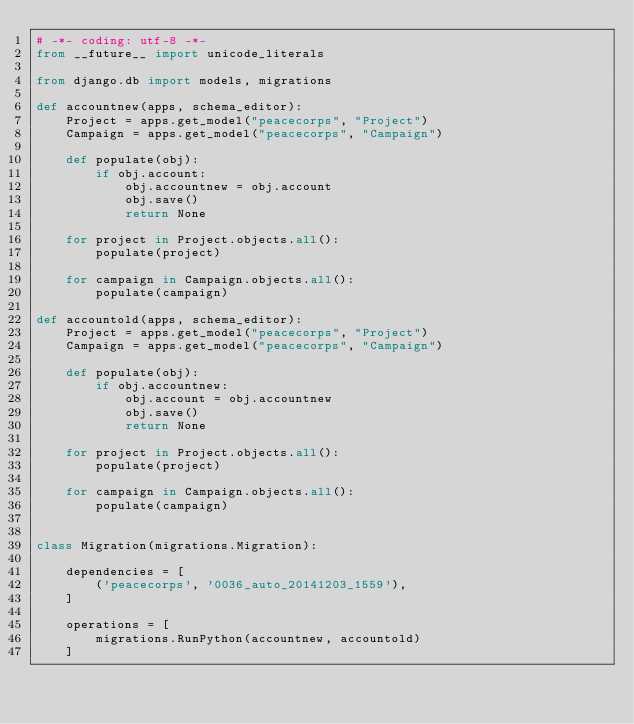<code> <loc_0><loc_0><loc_500><loc_500><_Python_># -*- coding: utf-8 -*-
from __future__ import unicode_literals

from django.db import models, migrations

def accountnew(apps, schema_editor):
    Project = apps.get_model("peacecorps", "Project")
    Campaign = apps.get_model("peacecorps", "Campaign")

    def populate(obj):
        if obj.account:
            obj.accountnew = obj.account
            obj.save()
            return None

    for project in Project.objects.all():
        populate(project)

    for campaign in Campaign.objects.all():
        populate(campaign)

def accountold(apps, schema_editor):
    Project = apps.get_model("peacecorps", "Project")
    Campaign = apps.get_model("peacecorps", "Campaign")  

    def populate(obj):
        if obj.accountnew:
            obj.account = obj.accountnew
            obj.save()
            return None

    for project in Project.objects.all():
        populate(project)

    for campaign in Campaign.objects.all():
        populate(campaign)


class Migration(migrations.Migration):

    dependencies = [
        ('peacecorps', '0036_auto_20141203_1559'),
    ]

    operations = [
        migrations.RunPython(accountnew, accountold)
    ]
</code> 